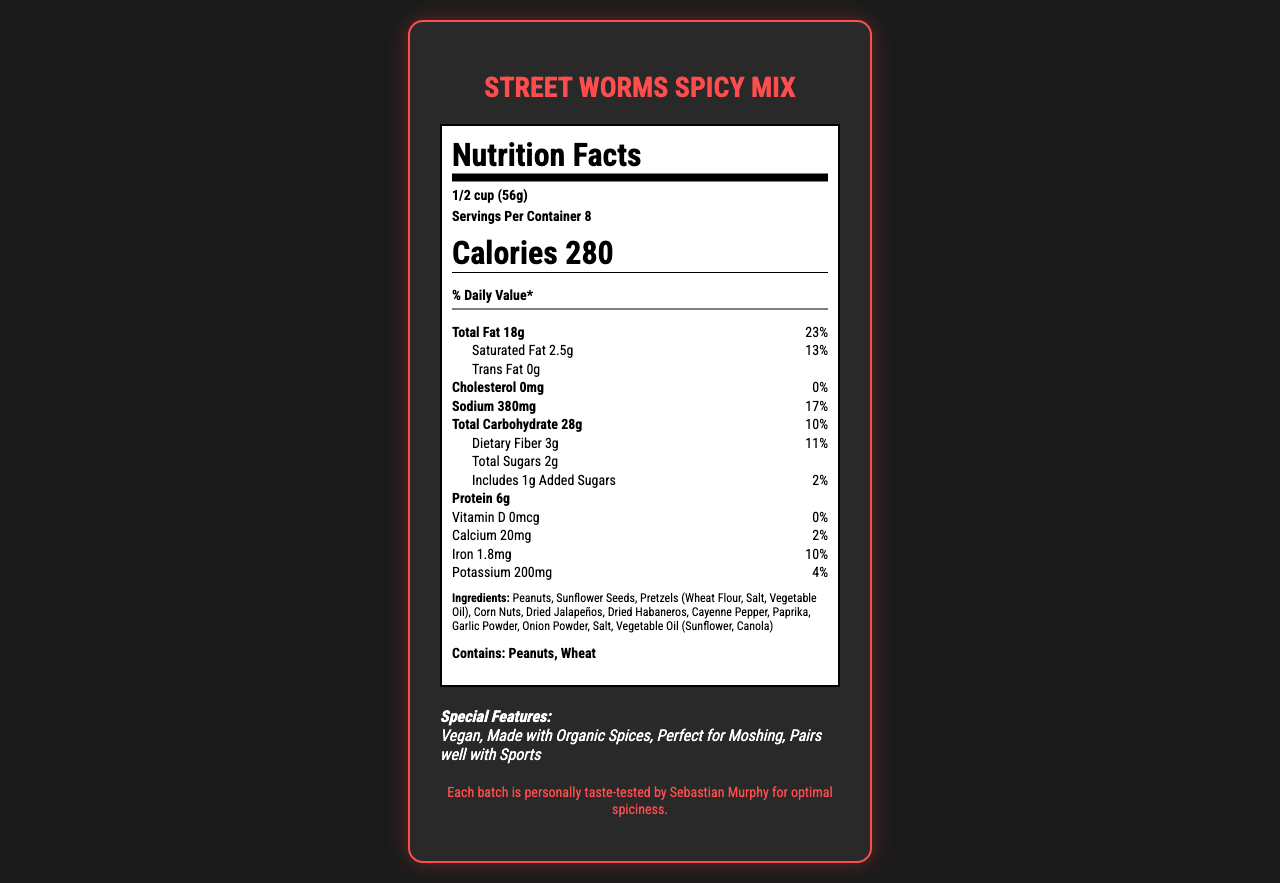what is the serving size? The serving size is explicitly mentioned at the top of the Nutrition Facts section of the document.
Answer: 1/2 cup (56g) how many calories are in one serving? The document states that one serving contains 280 calories, mentioned in bold within the Nutrition Facts section.
Answer: 280 calories how much protein does one serving contain? The protein content per serving is listed as 6g in the Nutrition Facts section.
Answer: 6g which special features are highlighted for the snack mix? The special features are listed towards the bottom section of the document under "Special Features."
Answer: Vegan, Made with Organic Spices, Perfect for Moshing, Pairs well with Sports what allergens are listed in the document? The allergen information is clearly stated near the bottom of the Nutrition Facts section under "Allergen Info."
Answer: Contains: Peanuts, Wheat how much sodium is in a single serving? The amount of sodium per serving is specified as 380mg in the Nutrition Facts section.
Answer: 380mg which of the following nuts are included in the ingredients? A. Almonds B. Peanuts C. Cashews D. Walnuts The ingredients list includes "Peanuts," confirming that Peanuts are part of the mix, but the other options are not listed.
Answer: B. Peanuts how much total fat is in a serving? A. 10g B. 15g C. 18g D. 20g The document states that the total fat per serving is 18g, clearly indicated in the Nutrition Facts section.
Answer: C. 18g is there any trans fat in this snack mix? The document specifies that there is 0g of trans fat per serving.
Answer: No does the snack contain any added sugars? The document lists 1g of added sugars per serving in the Nutrition Facts section.
Answer: Yes how much iron does one serving provide? The iron content per serving is listed as 1.8mg in the Nutrition Facts section.
Answer: 1.8mg does this spicy mix contain any vitamin D? The document states that there is 0mcg of Vitamin D per serving in the Nutrition Facts section.
Answer: No who personally taste-tests each batch of the snack mix? This information is provided in the "Fun Fact" section of the document.
Answer: Sebastian Murphy are there any vegetables included in the ingredients? The ingredients list includes items like "Dried Jalapeños" and "Dried Habaneros," but without more context, it's unclear if these are the only vegetable-derived ingredients.
Answer: Cannot be determined what is the main idea of the document? The document offers a comprehensive overview of the Street Worms Spicy Mix, including nutritional details, special features, and fun facts to attract potential consumers, especially those attending a Viagra Boys concert.
Answer: The main idea of the document is to provide detailed nutritional information, ingredients, allergen info, special features, and an interesting fun fact about the Street Worms Spicy Mix, making it clear it is both spicy and suitable for vegan diets. 